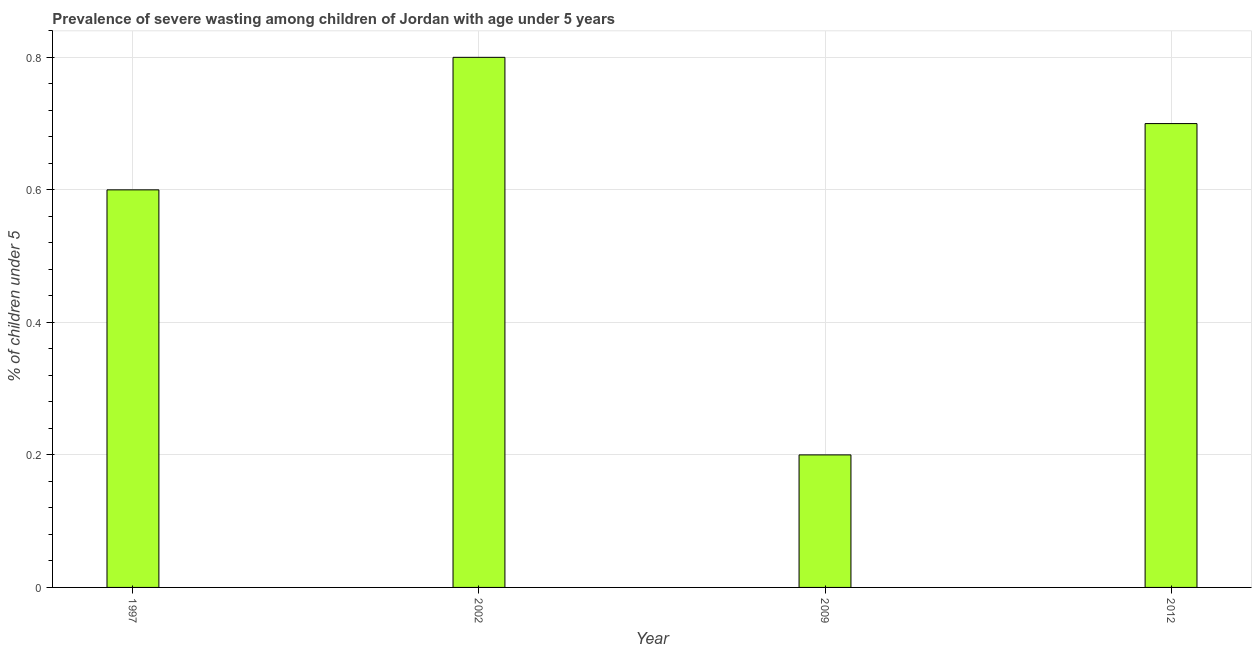What is the title of the graph?
Offer a very short reply. Prevalence of severe wasting among children of Jordan with age under 5 years. What is the label or title of the X-axis?
Give a very brief answer. Year. What is the label or title of the Y-axis?
Offer a very short reply.  % of children under 5. What is the prevalence of severe wasting in 2009?
Give a very brief answer. 0.2. Across all years, what is the maximum prevalence of severe wasting?
Offer a very short reply. 0.8. Across all years, what is the minimum prevalence of severe wasting?
Offer a terse response. 0.2. In which year was the prevalence of severe wasting maximum?
Your answer should be compact. 2002. In which year was the prevalence of severe wasting minimum?
Your response must be concise. 2009. What is the sum of the prevalence of severe wasting?
Give a very brief answer. 2.3. What is the difference between the prevalence of severe wasting in 2002 and 2012?
Provide a short and direct response. 0.1. What is the average prevalence of severe wasting per year?
Your answer should be very brief. 0.57. What is the median prevalence of severe wasting?
Ensure brevity in your answer.  0.65. Do a majority of the years between 2002 and 2009 (inclusive) have prevalence of severe wasting greater than 0.36 %?
Offer a terse response. No. What is the ratio of the prevalence of severe wasting in 2002 to that in 2012?
Give a very brief answer. 1.14. Is the prevalence of severe wasting in 2002 less than that in 2012?
Provide a succinct answer. No. Is the difference between the prevalence of severe wasting in 1997 and 2009 greater than the difference between any two years?
Your answer should be very brief. No. Is the sum of the prevalence of severe wasting in 1997 and 2012 greater than the maximum prevalence of severe wasting across all years?
Provide a short and direct response. Yes. What is the difference between the highest and the lowest prevalence of severe wasting?
Offer a terse response. 0.6. In how many years, is the prevalence of severe wasting greater than the average prevalence of severe wasting taken over all years?
Ensure brevity in your answer.  3. How many bars are there?
Keep it short and to the point. 4. Are all the bars in the graph horizontal?
Your answer should be compact. No. What is the difference between two consecutive major ticks on the Y-axis?
Give a very brief answer. 0.2. What is the  % of children under 5 of 1997?
Keep it short and to the point. 0.6. What is the  % of children under 5 of 2002?
Provide a succinct answer. 0.8. What is the  % of children under 5 of 2009?
Your answer should be very brief. 0.2. What is the  % of children under 5 of 2012?
Offer a terse response. 0.7. What is the difference between the  % of children under 5 in 2002 and 2009?
Provide a short and direct response. 0.6. What is the difference between the  % of children under 5 in 2002 and 2012?
Your answer should be very brief. 0.1. What is the difference between the  % of children under 5 in 2009 and 2012?
Your answer should be compact. -0.5. What is the ratio of the  % of children under 5 in 1997 to that in 2009?
Offer a terse response. 3. What is the ratio of the  % of children under 5 in 1997 to that in 2012?
Provide a succinct answer. 0.86. What is the ratio of the  % of children under 5 in 2002 to that in 2009?
Your response must be concise. 4. What is the ratio of the  % of children under 5 in 2002 to that in 2012?
Provide a short and direct response. 1.14. What is the ratio of the  % of children under 5 in 2009 to that in 2012?
Give a very brief answer. 0.29. 